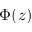Convert formula to latex. <formula><loc_0><loc_0><loc_500><loc_500>\Phi ( z )</formula> 